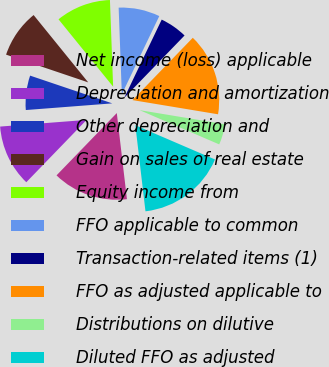Convert chart. <chart><loc_0><loc_0><loc_500><loc_500><pie_chart><fcel>Net income (loss) applicable<fcel>Depreciation and amortization<fcel>Other depreciation and<fcel>Gain on sales of real estate<fcel>Equity income from<fcel>FFO applicable to common<fcel>Transaction-related items (1)<fcel>FFO as adjusted applicable to<fcel>Distributions on dilutive<fcel>Diluted FFO as adjusted<nl><fcel>14.1%<fcel>11.54%<fcel>6.41%<fcel>8.97%<fcel>10.26%<fcel>7.69%<fcel>5.13%<fcel>15.38%<fcel>3.85%<fcel>16.67%<nl></chart> 